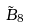Convert formula to latex. <formula><loc_0><loc_0><loc_500><loc_500>\tilde { B } _ { 8 }</formula> 